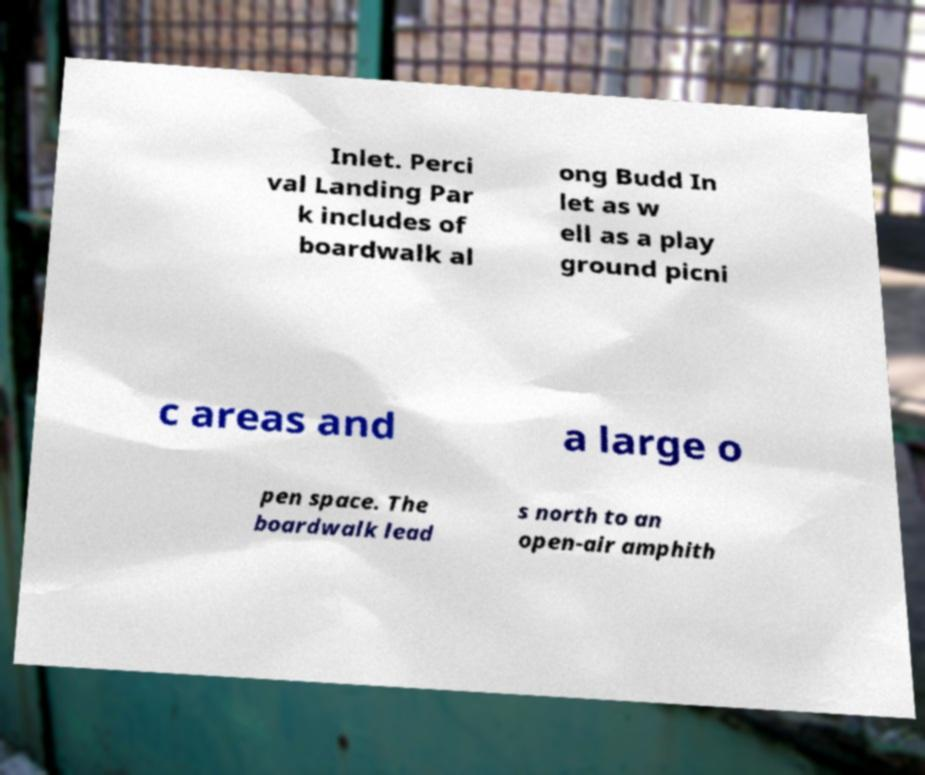There's text embedded in this image that I need extracted. Can you transcribe it verbatim? Inlet. Perci val Landing Par k includes of boardwalk al ong Budd In let as w ell as a play ground picni c areas and a large o pen space. The boardwalk lead s north to an open-air amphith 